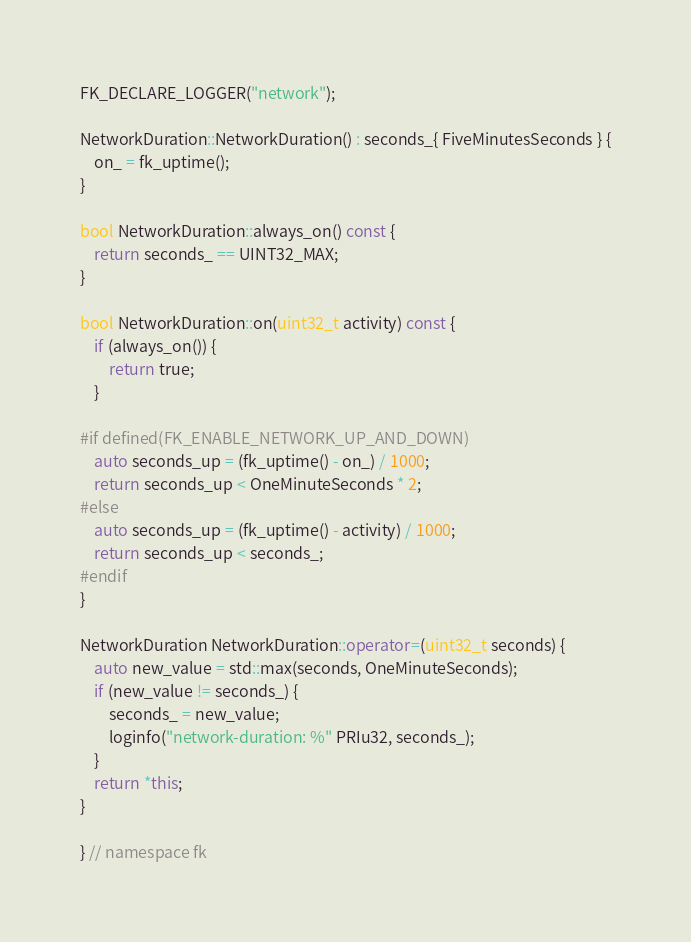<code> <loc_0><loc_0><loc_500><loc_500><_C++_>
FK_DECLARE_LOGGER("network");

NetworkDuration::NetworkDuration() : seconds_{ FiveMinutesSeconds } {
    on_ = fk_uptime();
}

bool NetworkDuration::always_on() const {
    return seconds_ == UINT32_MAX;
}

bool NetworkDuration::on(uint32_t activity) const {
    if (always_on()) {
        return true;
    }

#if defined(FK_ENABLE_NETWORK_UP_AND_DOWN)
    auto seconds_up = (fk_uptime() - on_) / 1000;
    return seconds_up < OneMinuteSeconds * 2;
#else
    auto seconds_up = (fk_uptime() - activity) / 1000;
    return seconds_up < seconds_;
#endif
}

NetworkDuration NetworkDuration::operator=(uint32_t seconds) {
    auto new_value = std::max(seconds, OneMinuteSeconds);
    if (new_value != seconds_) {
        seconds_ = new_value;
        loginfo("network-duration: %" PRIu32, seconds_);
    }
    return *this;
}

} // namespace fk
</code> 